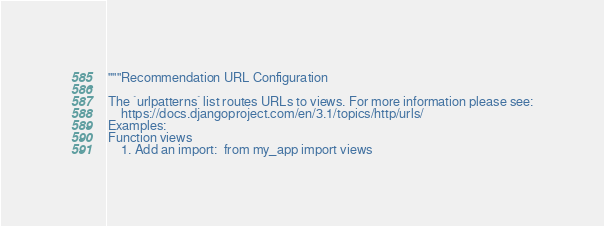<code> <loc_0><loc_0><loc_500><loc_500><_Python_>"""Recommendation URL Configuration

The `urlpatterns` list routes URLs to views. For more information please see:
    https://docs.djangoproject.com/en/3.1/topics/http/urls/
Examples:
Function views
    1. Add an import:  from my_app import views</code> 